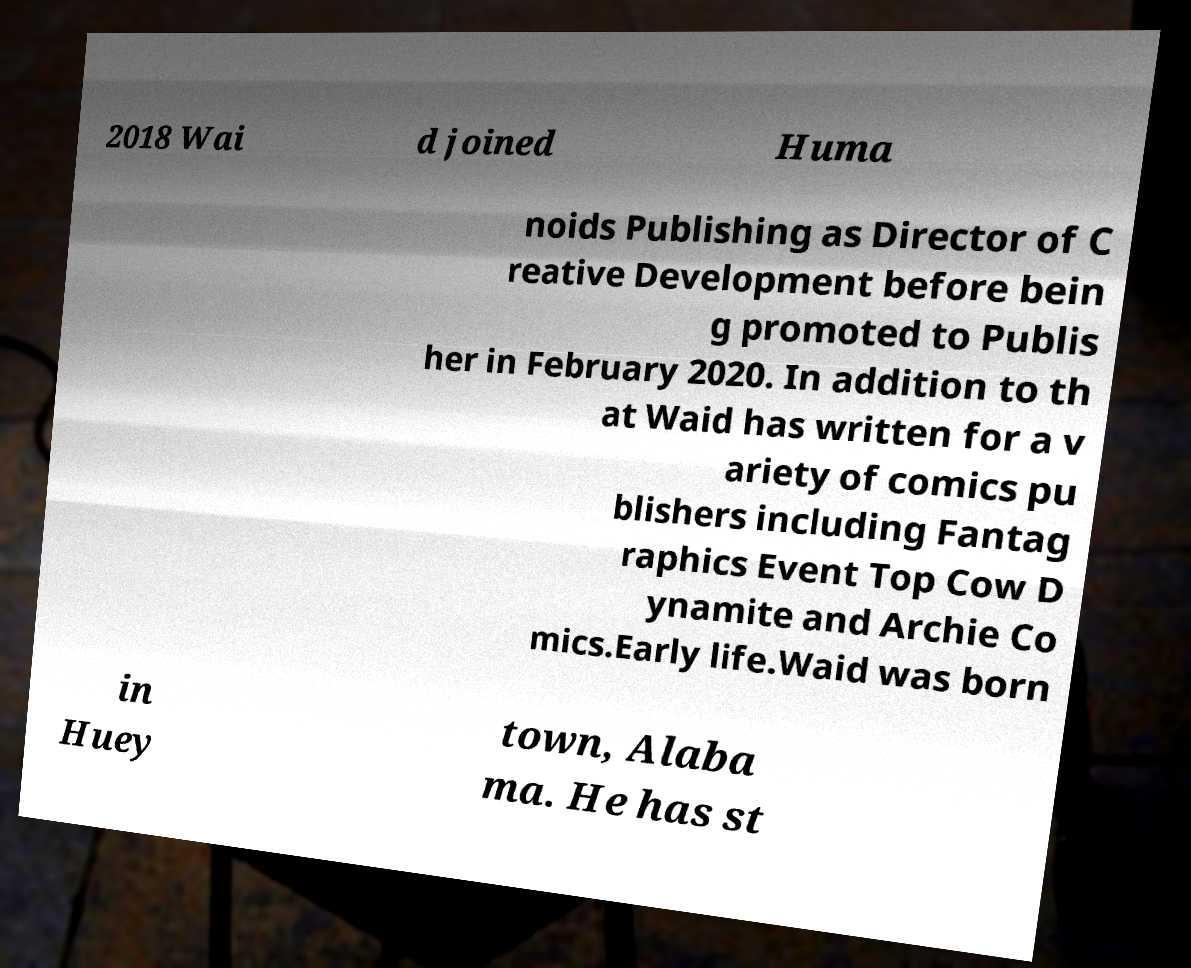Can you accurately transcribe the text from the provided image for me? 2018 Wai d joined Huma noids Publishing as Director of C reative Development before bein g promoted to Publis her in February 2020. In addition to th at Waid has written for a v ariety of comics pu blishers including Fantag raphics Event Top Cow D ynamite and Archie Co mics.Early life.Waid was born in Huey town, Alaba ma. He has st 